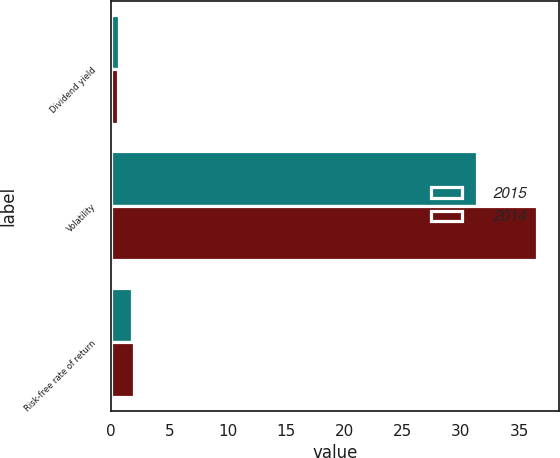Convert chart. <chart><loc_0><loc_0><loc_500><loc_500><stacked_bar_chart><ecel><fcel>Dividend yield<fcel>Volatility<fcel>Risk-free rate of return<nl><fcel>2015<fcel>0.69<fcel>31.37<fcel>1.78<nl><fcel>2014<fcel>0.6<fcel>36.55<fcel>1.94<nl></chart> 